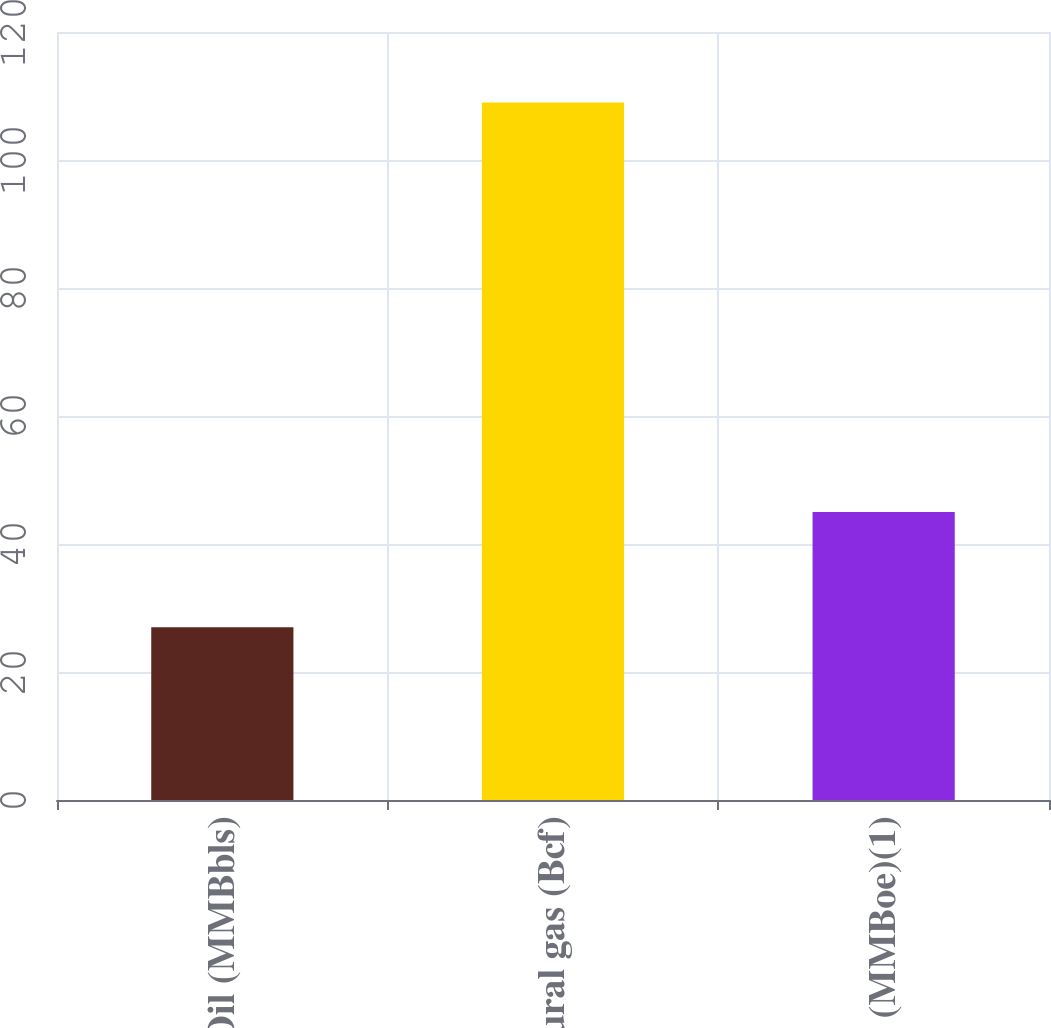Convert chart. <chart><loc_0><loc_0><loc_500><loc_500><bar_chart><fcel>Oil (MMBbls)<fcel>Natural gas (Bcf)<fcel>Total (MMBoe)(1)<nl><fcel>27<fcel>109<fcel>45<nl></chart> 